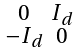<formula> <loc_0><loc_0><loc_500><loc_500>\begin{smallmatrix} 0 & I _ { d } \\ - I _ { d } & 0 \end{smallmatrix}</formula> 